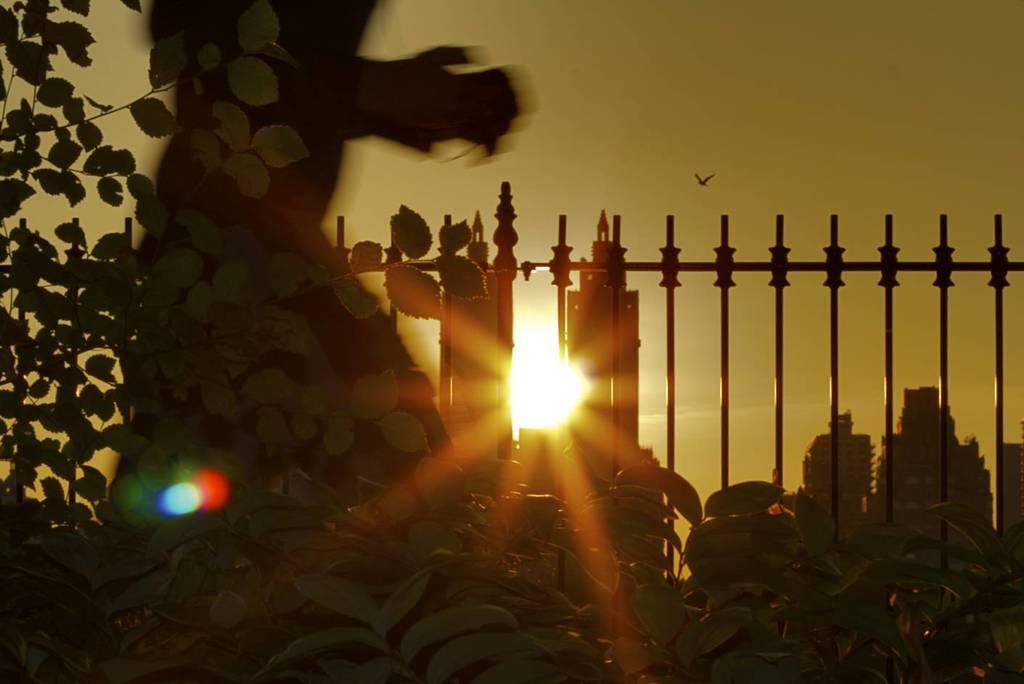What type of living organisms can be seen in the image? Plants can be seen in the image. What architectural feature is present in the image? There are iron grilles in the image. What type of structures are visible in the image? There are buildings in the image. Can you identify any human presence in the image? Yes, there is a person in the image. What can be seen in the sky in the background of the image? There is a bird flying in the sky in the background of the image. What type of dress is the bird wearing in the image? There is no bird wearing a dress in the image; it is simply flying in the sky. What type of peace can be observed between the plants and the iron grilles in the image? The concept of peace is not applicable to the relationship between plants and iron grilles in the image, as they are inanimate objects. 